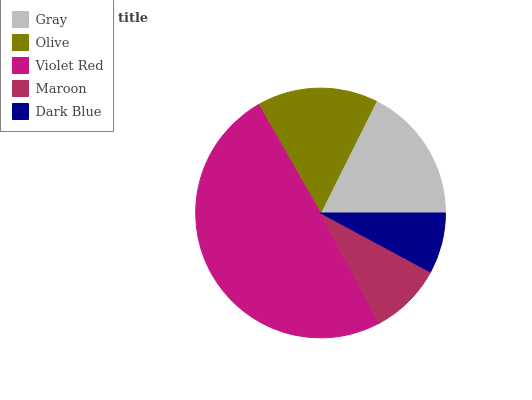Is Dark Blue the minimum?
Answer yes or no. Yes. Is Violet Red the maximum?
Answer yes or no. Yes. Is Olive the minimum?
Answer yes or no. No. Is Olive the maximum?
Answer yes or no. No. Is Gray greater than Olive?
Answer yes or no. Yes. Is Olive less than Gray?
Answer yes or no. Yes. Is Olive greater than Gray?
Answer yes or no. No. Is Gray less than Olive?
Answer yes or no. No. Is Olive the high median?
Answer yes or no. Yes. Is Olive the low median?
Answer yes or no. Yes. Is Violet Red the high median?
Answer yes or no. No. Is Violet Red the low median?
Answer yes or no. No. 